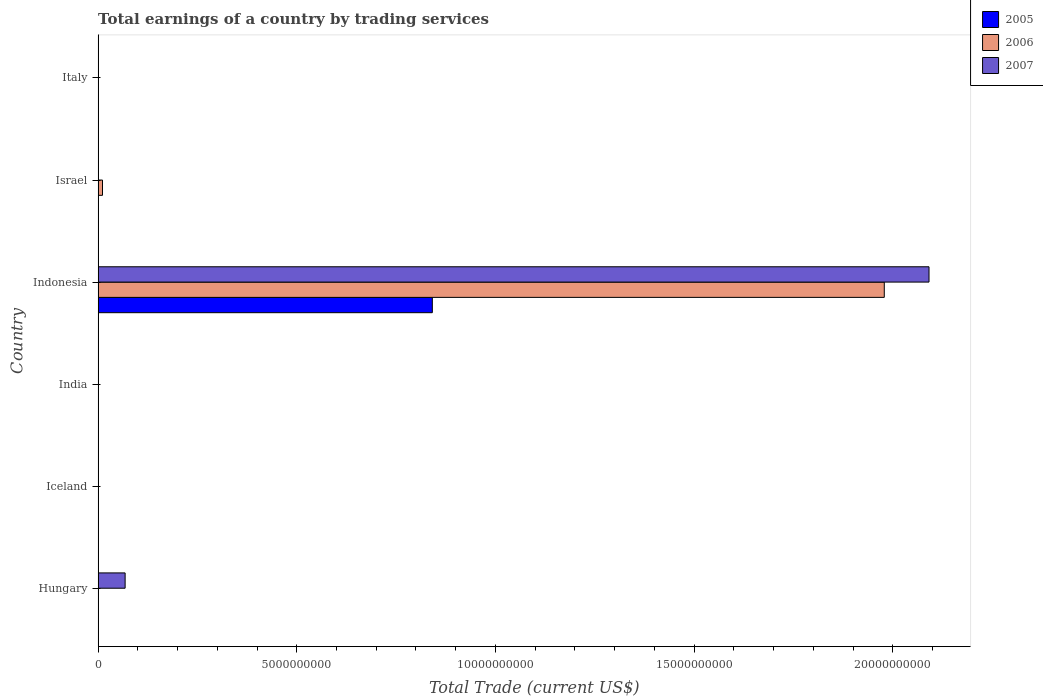Are the number of bars per tick equal to the number of legend labels?
Provide a succinct answer. No. How many bars are there on the 5th tick from the bottom?
Give a very brief answer. 1. What is the label of the 3rd group of bars from the top?
Give a very brief answer. Indonesia. What is the total earnings in 2006 in Indonesia?
Make the answer very short. 1.98e+1. Across all countries, what is the maximum total earnings in 2007?
Offer a very short reply. 2.09e+1. Across all countries, what is the minimum total earnings in 2006?
Your response must be concise. 0. In which country was the total earnings in 2006 maximum?
Provide a short and direct response. Indonesia. What is the total total earnings in 2005 in the graph?
Give a very brief answer. 8.41e+09. What is the difference between the total earnings in 2006 in Indonesia and that in Israel?
Keep it short and to the point. 1.97e+1. What is the average total earnings in 2007 per country?
Provide a succinct answer. 3.60e+09. What is the difference between the total earnings in 2006 and total earnings in 2005 in Indonesia?
Your answer should be very brief. 1.14e+1. In how many countries, is the total earnings in 2006 greater than 1000000000 US$?
Your answer should be compact. 1. What is the difference between the highest and the lowest total earnings in 2007?
Give a very brief answer. 2.09e+1. In how many countries, is the total earnings in 2007 greater than the average total earnings in 2007 taken over all countries?
Keep it short and to the point. 1. How many bars are there?
Provide a succinct answer. 5. Are all the bars in the graph horizontal?
Give a very brief answer. Yes. What is the difference between two consecutive major ticks on the X-axis?
Ensure brevity in your answer.  5.00e+09. Does the graph contain any zero values?
Provide a succinct answer. Yes. What is the title of the graph?
Ensure brevity in your answer.  Total earnings of a country by trading services. What is the label or title of the X-axis?
Make the answer very short. Total Trade (current US$). What is the Total Trade (current US$) of 2005 in Hungary?
Your answer should be compact. 0. What is the Total Trade (current US$) in 2007 in Hungary?
Make the answer very short. 6.80e+08. What is the Total Trade (current US$) in 2005 in Iceland?
Offer a very short reply. 0. What is the Total Trade (current US$) in 2006 in Iceland?
Provide a succinct answer. 0. What is the Total Trade (current US$) of 2007 in Iceland?
Provide a short and direct response. 0. What is the Total Trade (current US$) of 2005 in India?
Offer a terse response. 0. What is the Total Trade (current US$) of 2007 in India?
Provide a succinct answer. 0. What is the Total Trade (current US$) of 2005 in Indonesia?
Ensure brevity in your answer.  8.41e+09. What is the Total Trade (current US$) in 2006 in Indonesia?
Offer a very short reply. 1.98e+1. What is the Total Trade (current US$) of 2007 in Indonesia?
Your response must be concise. 2.09e+1. What is the Total Trade (current US$) of 2006 in Israel?
Provide a short and direct response. 1.10e+08. What is the Total Trade (current US$) in 2006 in Italy?
Provide a short and direct response. 0. Across all countries, what is the maximum Total Trade (current US$) of 2005?
Your answer should be very brief. 8.41e+09. Across all countries, what is the maximum Total Trade (current US$) in 2006?
Your answer should be very brief. 1.98e+1. Across all countries, what is the maximum Total Trade (current US$) of 2007?
Give a very brief answer. 2.09e+1. Across all countries, what is the minimum Total Trade (current US$) of 2006?
Offer a very short reply. 0. What is the total Total Trade (current US$) in 2005 in the graph?
Your response must be concise. 8.41e+09. What is the total Total Trade (current US$) in 2006 in the graph?
Provide a short and direct response. 1.99e+1. What is the total Total Trade (current US$) in 2007 in the graph?
Keep it short and to the point. 2.16e+1. What is the difference between the Total Trade (current US$) in 2007 in Hungary and that in Indonesia?
Provide a short and direct response. -2.02e+1. What is the difference between the Total Trade (current US$) in 2006 in Indonesia and that in Israel?
Your response must be concise. 1.97e+1. What is the difference between the Total Trade (current US$) of 2005 in Indonesia and the Total Trade (current US$) of 2006 in Israel?
Provide a short and direct response. 8.30e+09. What is the average Total Trade (current US$) of 2005 per country?
Give a very brief answer. 1.40e+09. What is the average Total Trade (current US$) in 2006 per country?
Provide a succinct answer. 3.32e+09. What is the average Total Trade (current US$) of 2007 per country?
Provide a short and direct response. 3.60e+09. What is the difference between the Total Trade (current US$) of 2005 and Total Trade (current US$) of 2006 in Indonesia?
Offer a very short reply. -1.14e+1. What is the difference between the Total Trade (current US$) of 2005 and Total Trade (current US$) of 2007 in Indonesia?
Offer a very short reply. -1.25e+1. What is the difference between the Total Trade (current US$) of 2006 and Total Trade (current US$) of 2007 in Indonesia?
Offer a terse response. -1.13e+09. What is the ratio of the Total Trade (current US$) of 2007 in Hungary to that in Indonesia?
Your answer should be very brief. 0.03. What is the ratio of the Total Trade (current US$) of 2006 in Indonesia to that in Israel?
Provide a succinct answer. 179.55. What is the difference between the highest and the lowest Total Trade (current US$) of 2005?
Your answer should be very brief. 8.41e+09. What is the difference between the highest and the lowest Total Trade (current US$) in 2006?
Your answer should be very brief. 1.98e+1. What is the difference between the highest and the lowest Total Trade (current US$) of 2007?
Ensure brevity in your answer.  2.09e+1. 